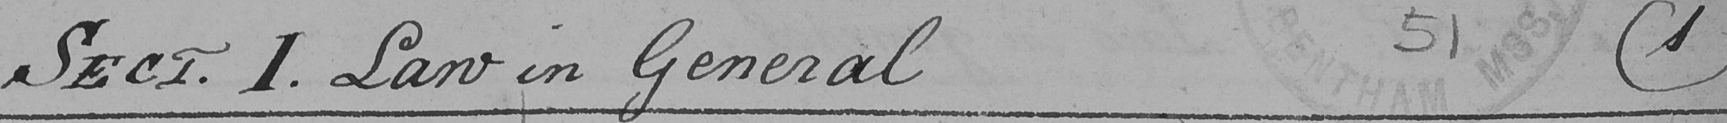Please provide the text content of this handwritten line. SECT . 1 . Law in General  ( 1 